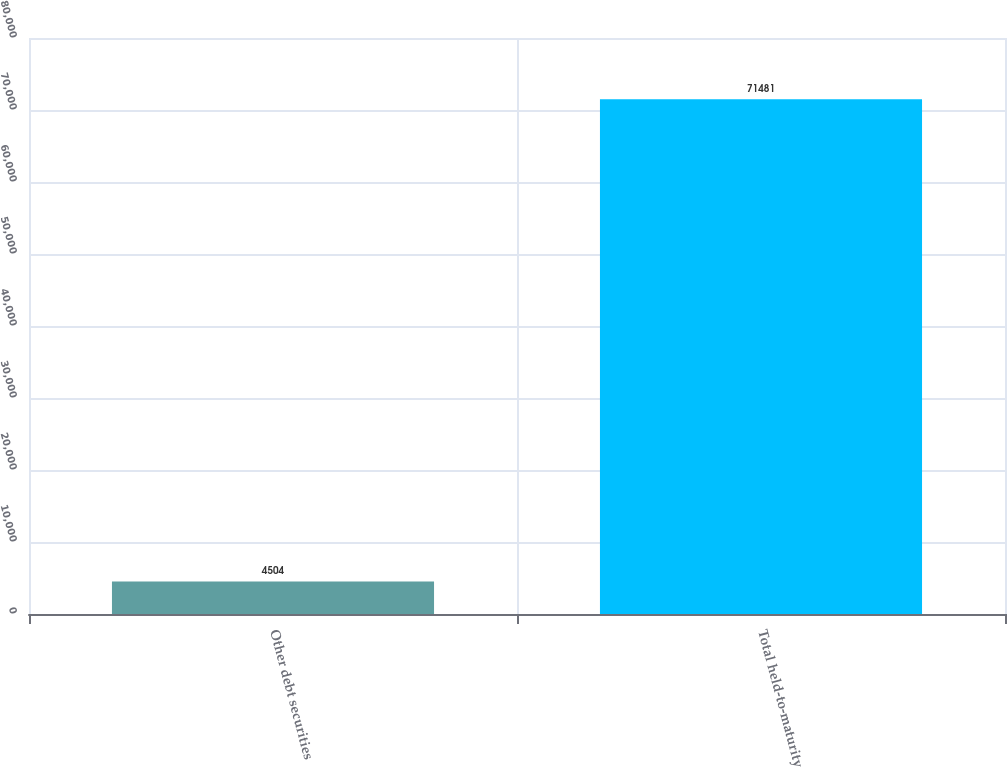<chart> <loc_0><loc_0><loc_500><loc_500><bar_chart><fcel>Other debt securities<fcel>Total held-to-maturity<nl><fcel>4504<fcel>71481<nl></chart> 